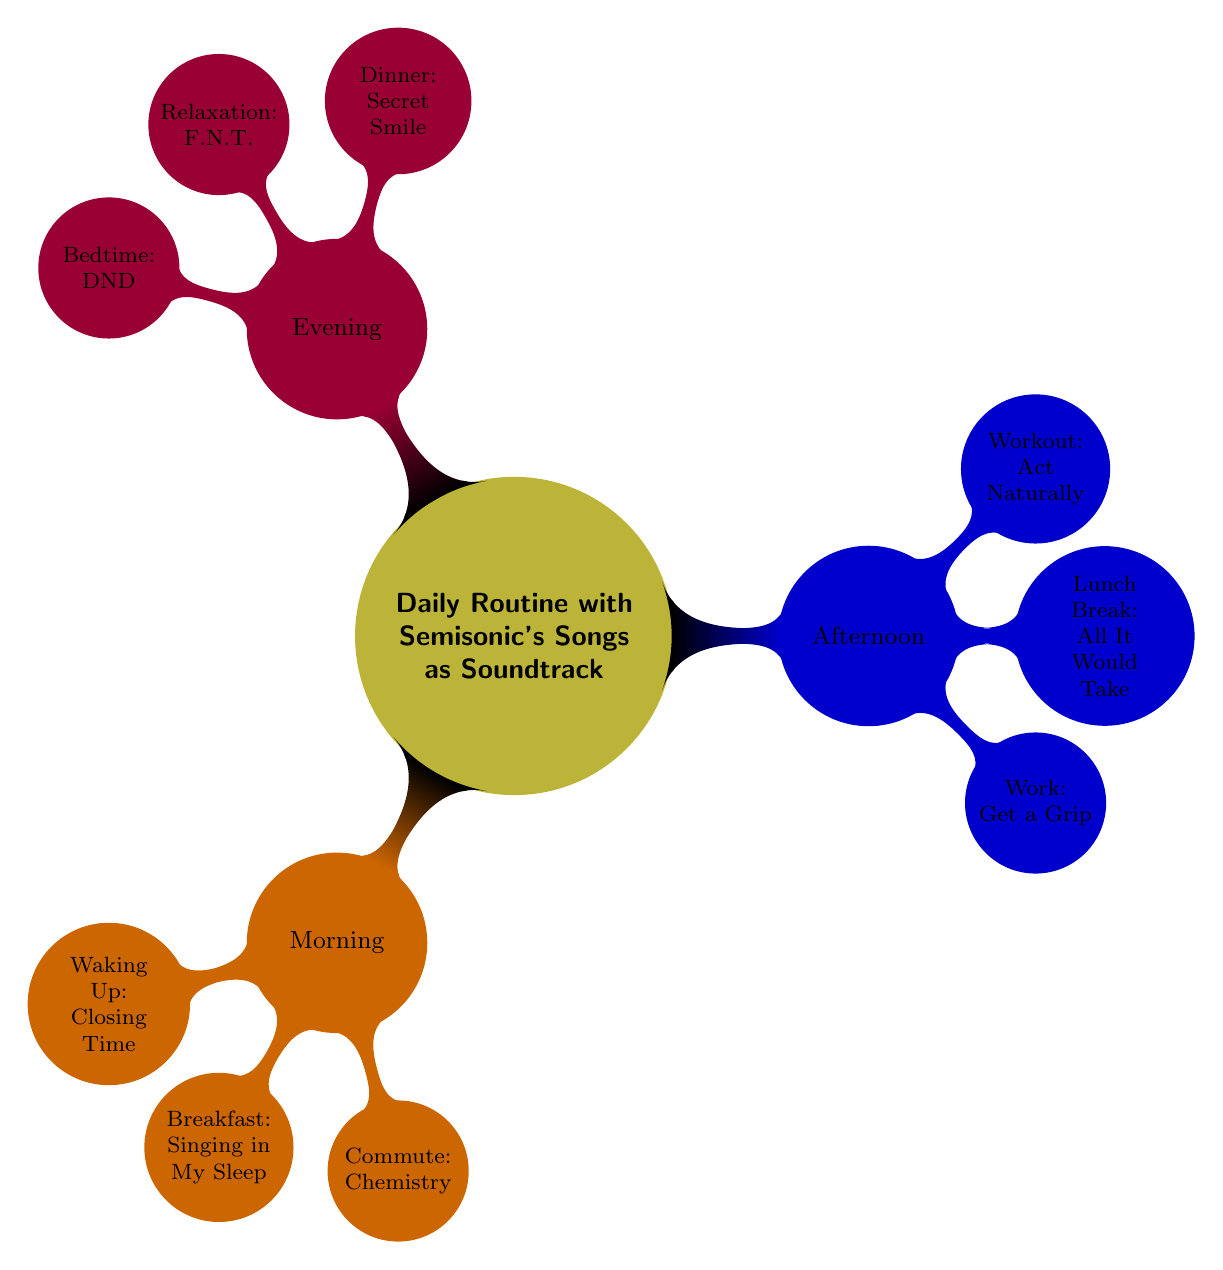What song is associated with waking up? In the "Morning" section of the diagram, the node for "Waking Up" specifies the song "Closing Time."
Answer: Closing Time How many activities are listed under "Afternoon"? Under the "Afternoon" section, there are three activities listed: Work, Lunch Break, and Workout. Thus, the total number of activities is three.
Answer: 3 What is the song played during relaxation time? In the "Evening" section, the node for "Relaxation" specifies the song "F.N.T."
Answer: F.N.T Which song is associated with dinner? In the "Evening" section, the node for "Dinner" specifies the song "Secret Smile."
Answer: Secret Smile What is the relationship between "Breakfast" and "Singing in My Sleep"? "Breakfast" is a node under the "Morning" section, and it is directly linked to the song "Singing in My Sleep." This indicates that "Singing in My Sleep" is the soundtrack for breakfast.
Answer: Breakfast relates to Singing in My Sleep Which song is played during the commute? In the "Morning" section, the node for "Commute" specifies the song "Chemistry."
Answer: Chemistry What activities are associated with the evening routine? In the "Evening" section, there are three activities listed: Dinner, Relaxation, and Bedtime. Each activity has its corresponding song.
Answer: Dinner, Relaxation, Bedtime What song is played during the workout? In the "Afternoon" section, the node for "Workout" specifies the song "Act Naturally."
Answer: Act Naturally What is the first activity of the daily routine? The first activity listed in the "Morning" section is "Waking Up."
Answer: Waking Up 